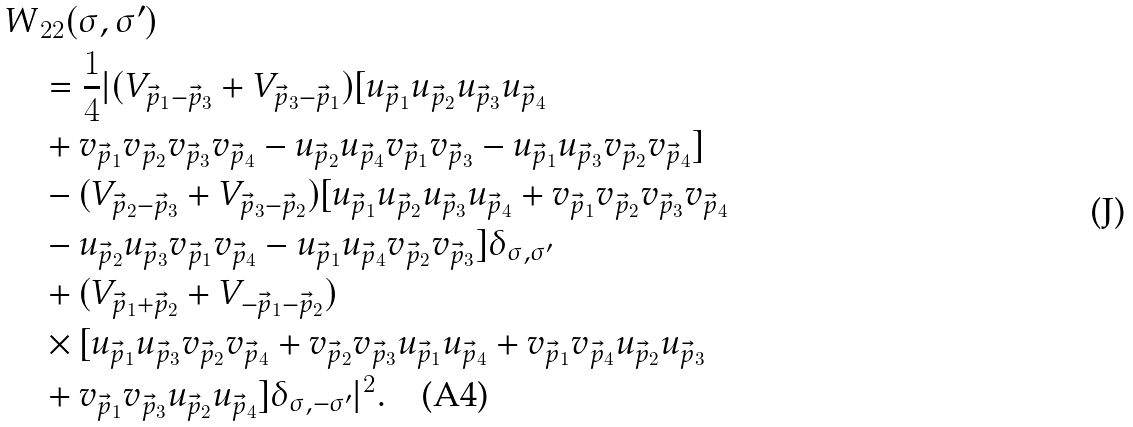<formula> <loc_0><loc_0><loc_500><loc_500>W & _ { 2 2 } ( \sigma , \sigma ^ { \prime } ) \\ & = \frac { 1 } { 4 } | ( V _ { \vec { p } _ { 1 } - \vec { p } _ { 3 } } + V _ { \vec { p } _ { 3 } - \vec { p } _ { 1 } } ) [ u _ { \vec { p } _ { 1 } } u _ { \vec { p } _ { 2 } } u _ { \vec { p } _ { 3 } } u _ { \vec { p } _ { 4 } } \\ & + v _ { \vec { p } _ { 1 } } v _ { \vec { p } _ { 2 } } v _ { \vec { p } _ { 3 } } v _ { \vec { p } _ { 4 } } - u _ { \vec { p } _ { 2 } } u _ { \vec { p } _ { 4 } } v _ { \vec { p } _ { 1 } } v _ { \vec { p } _ { 3 } } - u _ { \vec { p } _ { 1 } } u _ { \vec { p } _ { 3 } } v _ { \vec { p } _ { 2 } } v _ { \vec { p } _ { 4 } } ] \\ & - ( V _ { \vec { p } _ { 2 } - \vec { p } _ { 3 } } + V _ { \vec { p } _ { 3 } - \vec { p } _ { 2 } } ) [ u _ { \vec { p } _ { 1 } } u _ { \vec { p } _ { 2 } } u _ { \vec { p } _ { 3 } } u _ { \vec { p } _ { 4 } } + v _ { \vec { p } _ { 1 } } v _ { \vec { p } _ { 2 } } v _ { \vec { p } _ { 3 } } v _ { \vec { p } _ { 4 } } \\ & - u _ { \vec { p } _ { 2 } } u _ { \vec { p } _ { 3 } } v _ { \vec { p } _ { 1 } } v _ { \vec { p } _ { 4 } } - u _ { \vec { p } _ { 1 } } u _ { \vec { p } _ { 4 } } v _ { \vec { p } _ { 2 } } v _ { \vec { p } _ { 3 } } ] \delta _ { \sigma , \sigma ^ { \prime } } \\ & + ( V _ { \vec { p } _ { 1 } + \vec { p } _ { 2 } } + V _ { - \vec { p } _ { 1 } - \vec { p } _ { 2 } } ) \\ & \times [ u _ { \vec { p } _ { 1 } } u _ { \vec { p } _ { 3 } } v _ { \vec { p } _ { 2 } } v _ { \vec { p } _ { 4 } } + v _ { \vec { p } _ { 2 } } v _ { \vec { p } _ { 3 } } u _ { \vec { p } _ { 1 } } u _ { \vec { p } _ { 4 } } + v _ { \vec { p } _ { 1 } } v _ { \vec { p } _ { 4 } } u _ { \vec { p } _ { 2 } } u _ { \vec { p } _ { 3 } } \\ & + v _ { \vec { p } _ { 1 } } v _ { \vec { p } _ { 3 } } u _ { \vec { p } _ { 2 } } u _ { \vec { p } _ { 4 } } ] \delta _ { \sigma , - \sigma ^ { \prime } } | ^ { 2 } . \quad \text {(A4)}</formula> 